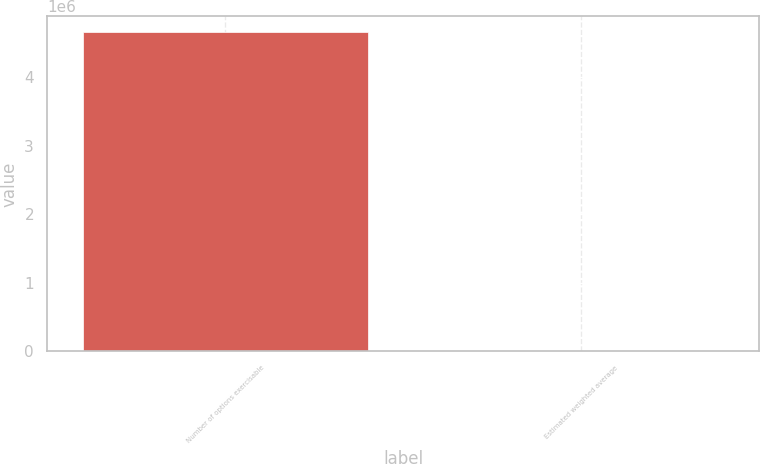Convert chart to OTSL. <chart><loc_0><loc_0><loc_500><loc_500><bar_chart><fcel>Number of options exercisable<fcel>Estimated weighted average<nl><fcel>4.65677e+06<fcel>32.2<nl></chart> 